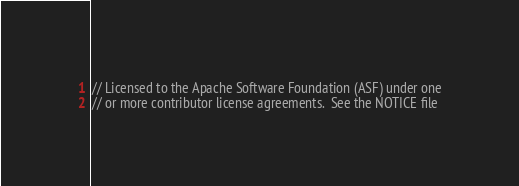Convert code to text. <code><loc_0><loc_0><loc_500><loc_500><_C++_>// Licensed to the Apache Software Foundation (ASF) under one
// or more contributor license agreements.  See the NOTICE file</code> 